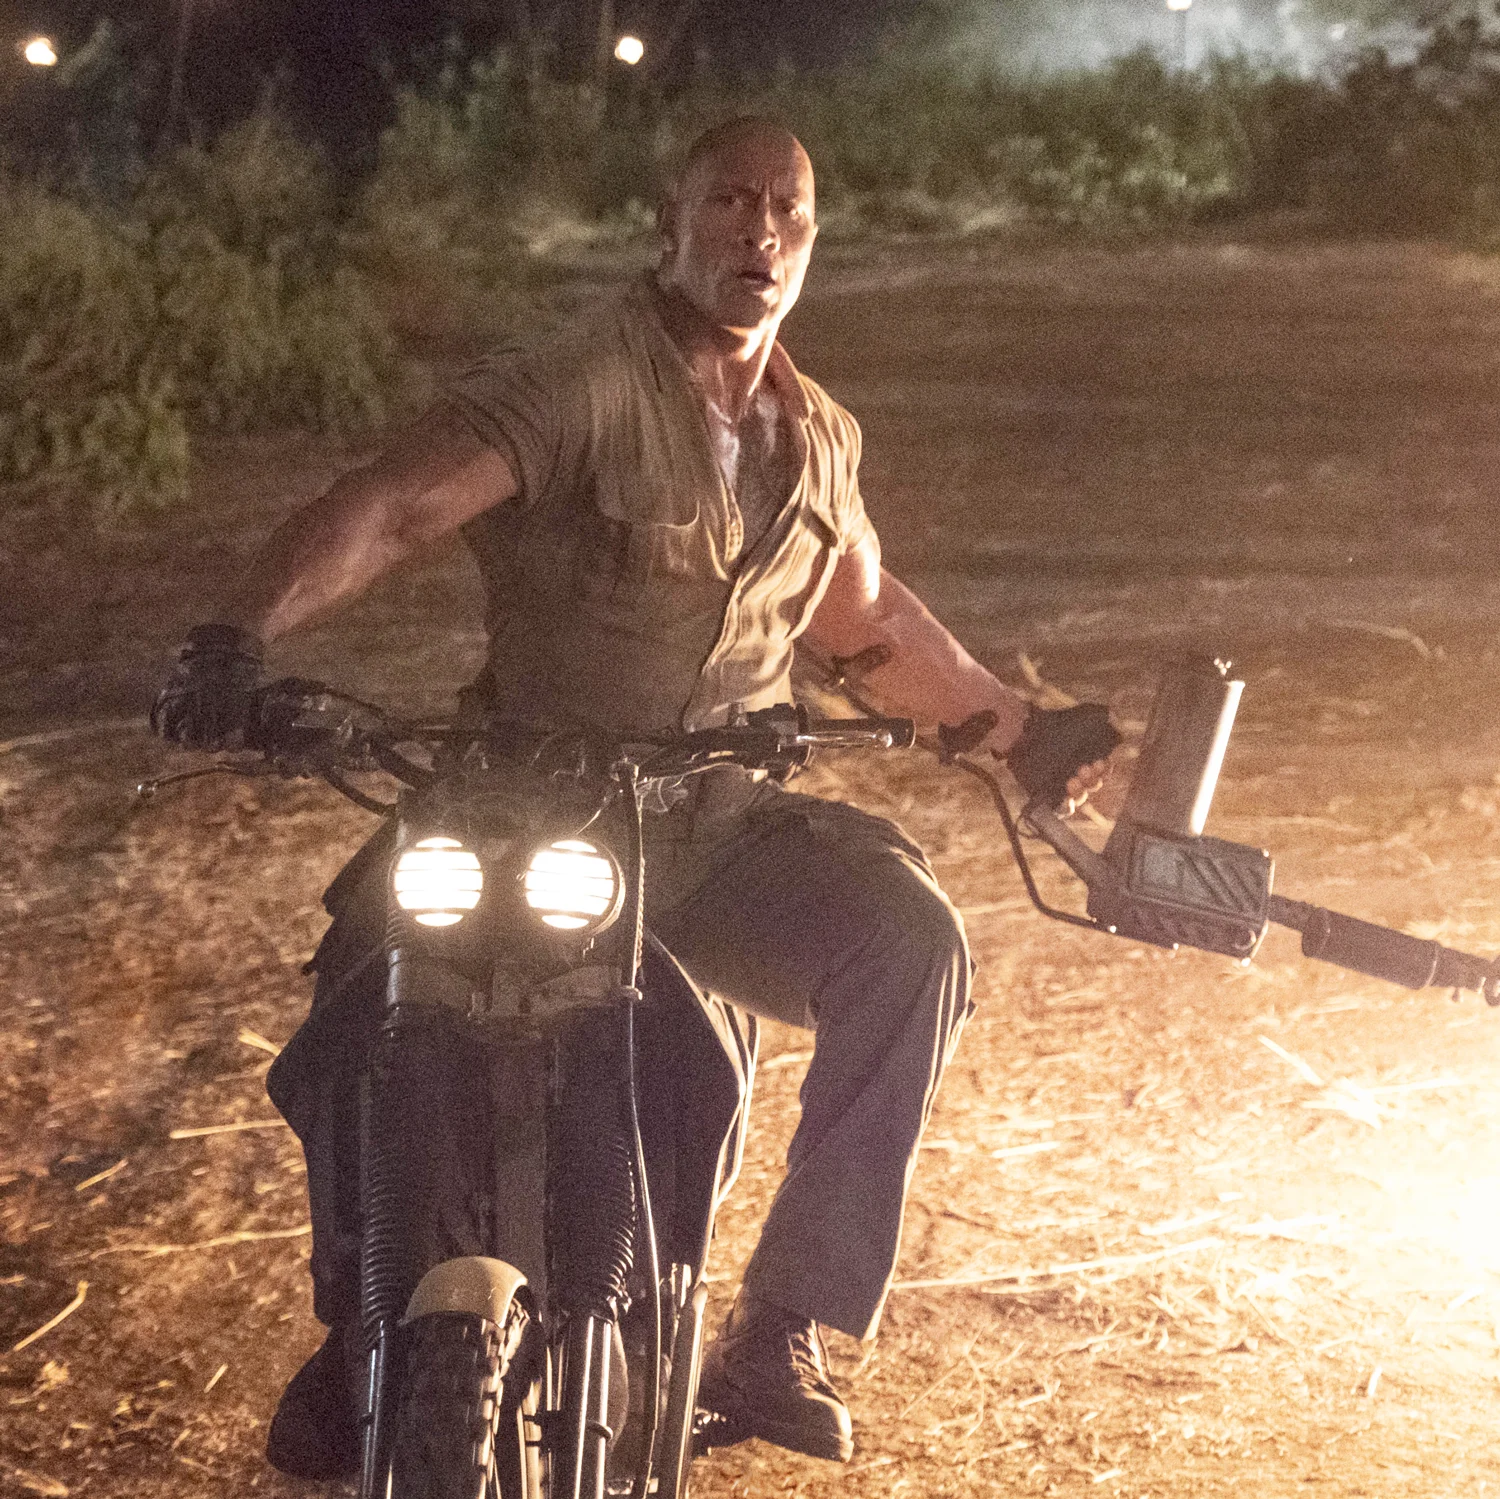What does the setting suggest about the scene depicted in the image? The setting, characterized by its night-time backdrop and sparse, dusty environment, suggests an adventurous or perilous scenario, possibly in a remote or wild location. The presence of the motorcycle and the mounted gun adds a sense of urgency and readiness for combat or a swift escape. 